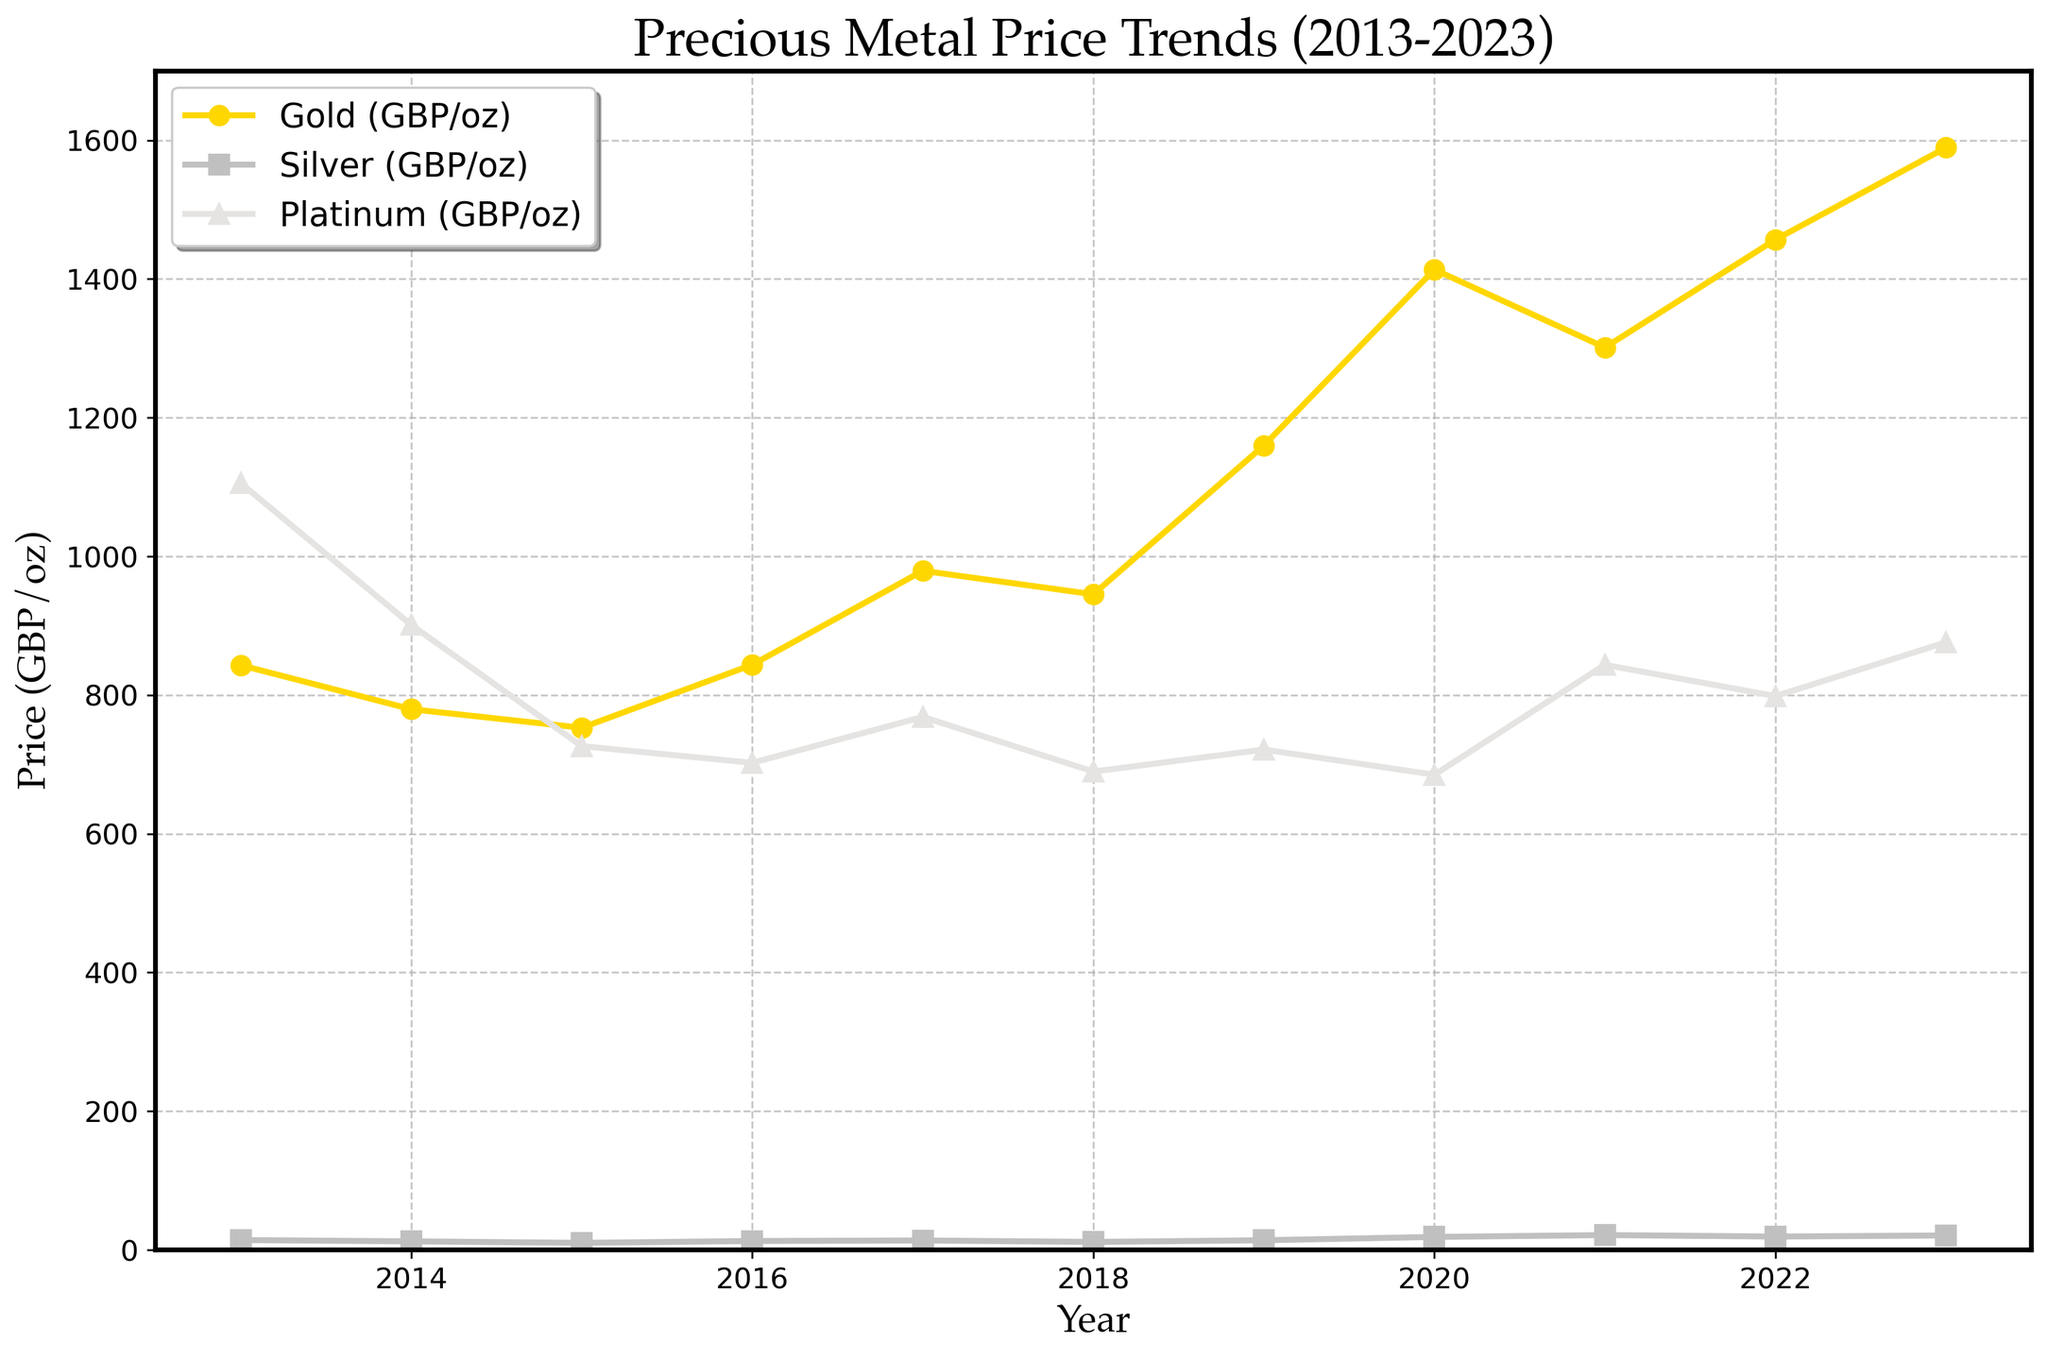What is the price difference between Gold and Platinum in 2020? From the figure, look at the prices for Gold and Platinum in 2020. The price of Gold is 1413.56 GBP/oz, and the price of Platinum is 685.23 GBP/oz. Subtract the Platinum price from the Gold price: 1413.56 - 685.23.
Answer: 728.33 GBP/oz How did the price of Silver change from 2015 to 2020? Check the Silver price in 2015 and 2020. The price in 2015 is 10.21 GBP/oz, and in 2020, it is 18.76 GBP/oz. Subtract the 2015 price from the 2020 price: 18.76 - 10.21.
Answer: Increased by 8.55 GBP/oz Which metal had the highest price in 2023? Observe the prices for Gold, Silver, and Platinum in 2023. Gold is 1589.34 GBP/oz, Silver is 20.87 GBP/oz, and Platinum is 876.12 GBP/oz. Gold has the highest value.
Answer: Gold Between which years did Platinum experience its highest price drop? Identify the years where Platinum's price drop is the greatest. The steepest decrease is between 2013 (1105.68 GBP/oz) and 2014 (901.23 GBP/oz), a drop of 1105.68 - 901.23.
Answer: 2013 to 2014 What was the general trend in Gold prices between 2016 and 2020? Examine Gold prices from 2016 to 2020: 843.76 in 2016, 979.23 in 2017, 945.32 in 2018, 1159.87 in 2019, and 1413.56 in 2020. The prices generally increased over these years.
Answer: Increased Calculate the average price of Silver from 2013 to 2023. Sum the Silver prices from 2013 to 2023 and divide by the number of years: (14.27 + 12.38 + 10.21 + 12.89 + 13.67 + 11.54 + 13.98 + 18.76 + 21.45 + 19.32 + 20.87) / 11
Answer: 15.86 GBP/oz Did Gold or Platinum have a greater price increase from 2019 to 2023? Check the Gold price in 2019 and 2023 (1159.87 to 1589.34) and the Platinum price in 2019 and 2023 (721.45 to 876.12). Calculate the increase for both: Gold increased by 429.47, and Platinum increased by 154.67. Gold had a greater increase.
Answer: Gold Which metal had the least price fluctuation over the decade? Determine fluctuation by seeing the range in prices. Gold: 1589.34 - 752.89, Silver: 21.45 - 10.21, Platinum: 1105.68 - 685.23. Platinum has the smallest range (420.45).
Answer: Platinum 